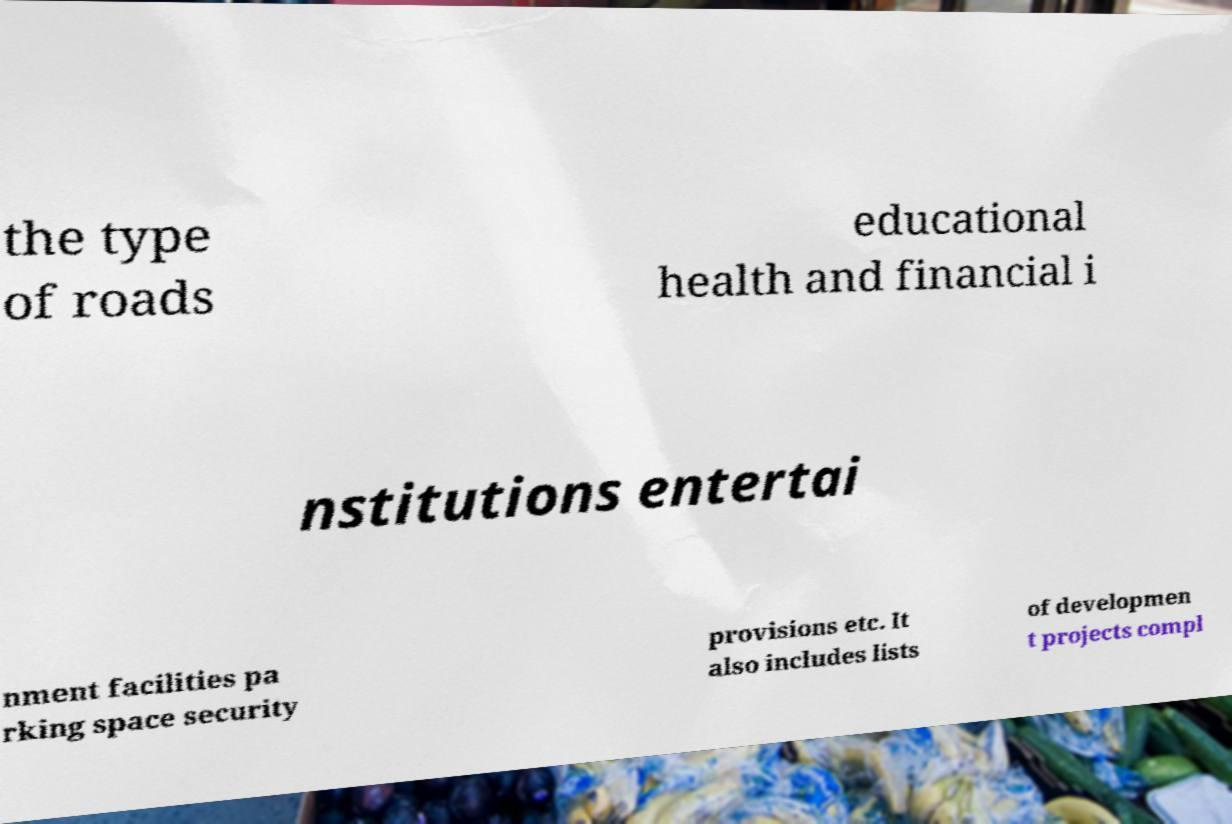Can you read and provide the text displayed in the image?This photo seems to have some interesting text. Can you extract and type it out for me? the type of roads educational health and financial i nstitutions entertai nment facilities pa rking space security provisions etc. It also includes lists of developmen t projects compl 